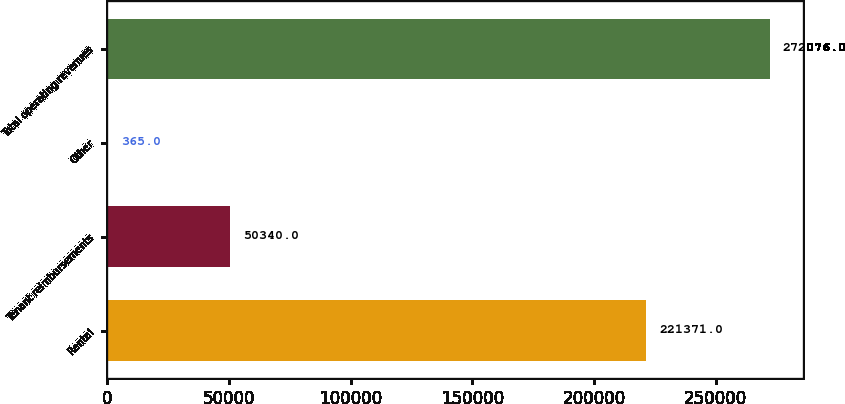Convert chart to OTSL. <chart><loc_0><loc_0><loc_500><loc_500><bar_chart><fcel>Rental<fcel>Tenant reimbursements<fcel>Other<fcel>Total operating revenues<nl><fcel>221371<fcel>50340<fcel>365<fcel>272076<nl></chart> 